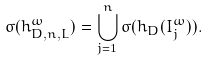Convert formula to latex. <formula><loc_0><loc_0><loc_500><loc_500>\sigma ( h _ { D , n , L } ^ { \omega } ) = \bigcup _ { j = 1 } ^ { n } \sigma ( h _ { D } ( I _ { j } ^ { \omega } ) ) .</formula> 